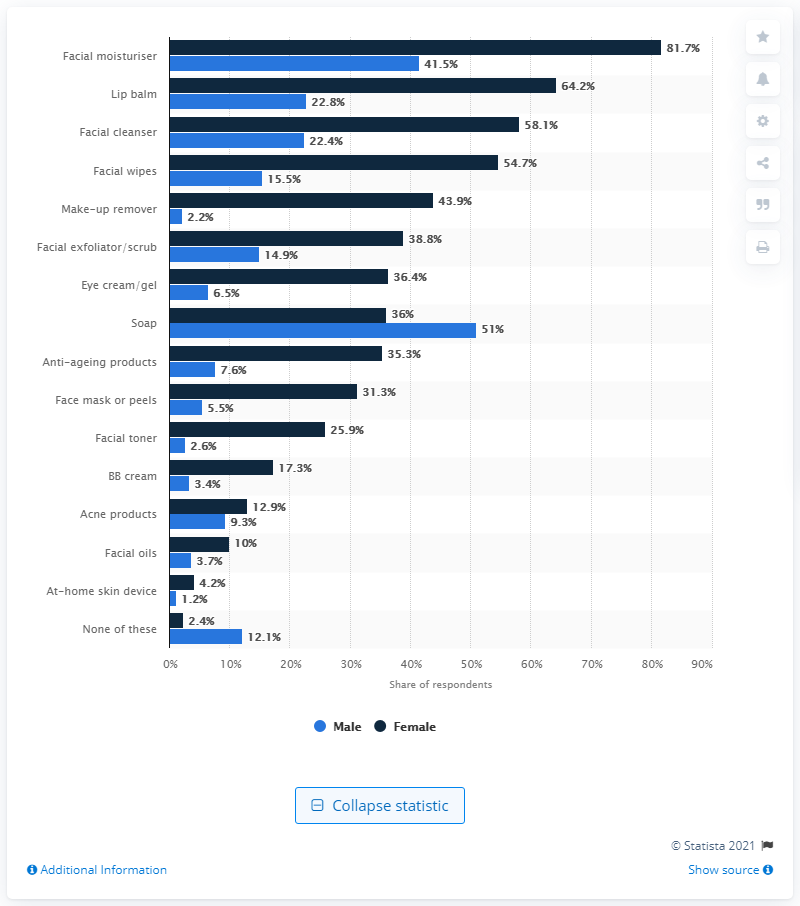Indicate a few pertinent items in this graphic. The most commonly used skin care product among males in the past 12 months is soap. According to our analysis, the at-home skin device appears to have the minimum difference between the amount of skin products used by male and female customers. 